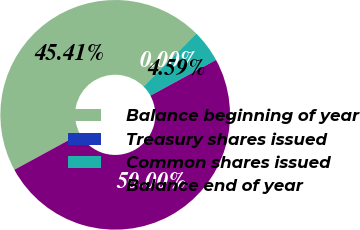<chart> <loc_0><loc_0><loc_500><loc_500><pie_chart><fcel>Balance beginning of year<fcel>Treasury shares issued<fcel>Common shares issued<fcel>Balance end of year<nl><fcel>45.41%<fcel>0.0%<fcel>4.59%<fcel>50.0%<nl></chart> 